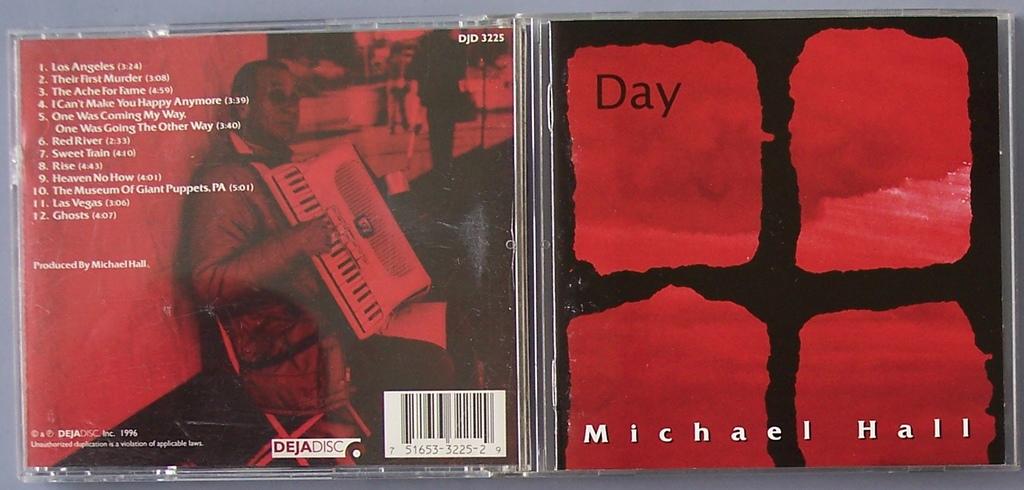Whats the na,e of this album?
Make the answer very short. Day. Who is the artist?
Your response must be concise. Michael hall. 